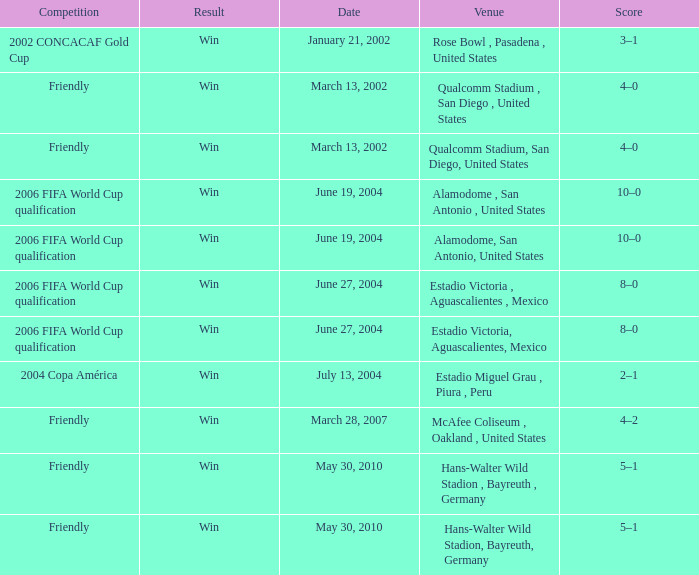What date has alamodome, san antonio, united states as the venue? June 19, 2004, June 19, 2004. 